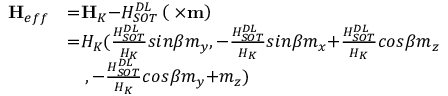Convert formula to latex. <formula><loc_0><loc_0><loc_500><loc_500>\begin{array} { l l } { { H } _ { e f f } } & { { = } { H } _ { K } { - } H _ { S O T } ^ { D L } \left ( { \sigma } { \times } { m } \right ) } \\ & { { = } H _ { K } ( \frac { H _ { S O T } ^ { D L } } { H _ { K } } { \sin } \beta m _ { y } { , - } \frac { H _ { S O T } ^ { D L } } { H _ { K } } { \sin } \beta m _ { x } { + } \frac { H _ { S O T } ^ { D L } } { H _ { K } } { \cos } \beta m _ { z } } \\ & { \quad , - \frac { H _ { S O T } ^ { D L } } { H _ { K } } { \cos } \beta m _ { y } { + } m _ { z } ) } \end{array}</formula> 